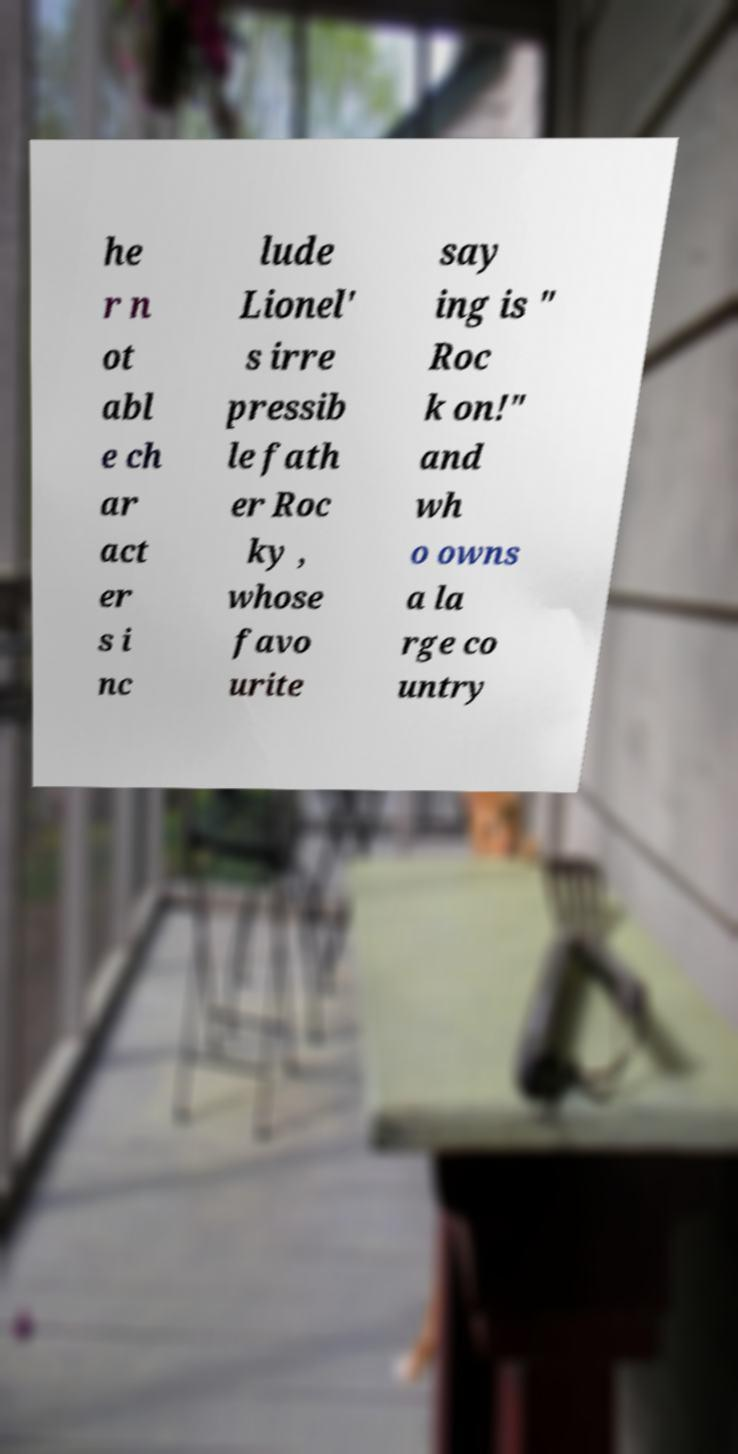I need the written content from this picture converted into text. Can you do that? he r n ot abl e ch ar act er s i nc lude Lionel' s irre pressib le fath er Roc ky , whose favo urite say ing is " Roc k on!" and wh o owns a la rge co untry 